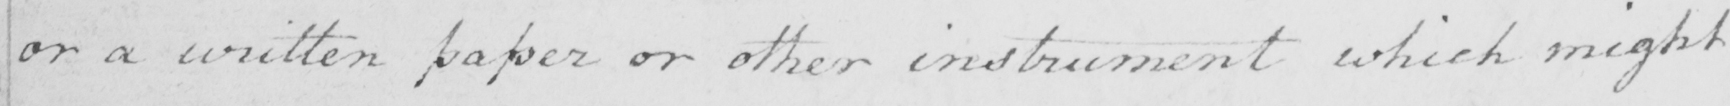Can you tell me what this handwritten text says? or a written paper or other instrument which might 